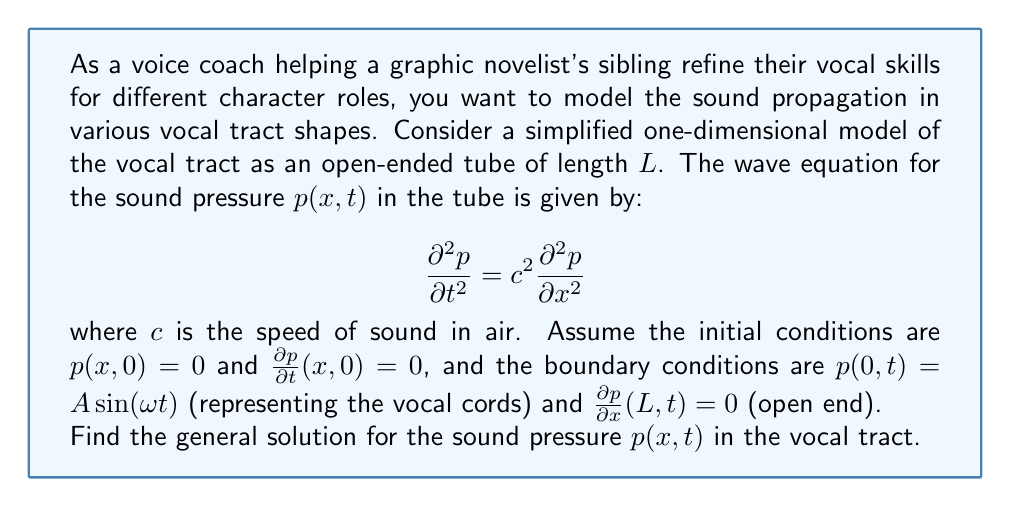Teach me how to tackle this problem. To solve this problem, we'll use the method of separation of variables and follow these steps:

1) Assume a solution of the form $p(x,t) = X(x)T(t)$.

2) Substitute this into the wave equation:
   $$X(x)T''(t) = c^2X''(x)T(t)$$

3) Separate variables:
   $$\frac{T''(t)}{c^2T(t)} = \frac{X''(x)}{X(x)} = -k^2$$

4) This gives us two ordinary differential equations:
   $$T''(t) + c^2k^2T(t) = 0$$
   $$X''(x) + k^2X(x) = 0$$

5) The general solutions are:
   $$T(t) = A\cos(ckt) + B\sin(ckt)$$
   $$X(x) = C\cos(kx) + D\sin(kx)$$

6) Apply the boundary condition at $x=L$:
   $$\frac{\partial p}{\partial x}(L,t) = 0 \implies X'(L) = 0$$
   $$-Ck\sin(kL) + Dk\cos(kL) = 0$$

7) This gives us the eigenvalue equation:
   $$\tan(kL) = \infty \implies kL = (2n-1)\frac{\pi}{2}, n = 1,2,3,...$$

8) The eigenvalues are:
   $$k_n = \frac{(2n-1)\pi}{2L}, n = 1,2,3,...$$

9) The corresponding eigenfunctions are:
   $$X_n(x) = \cos(k_nx)$$

10) The general solution is:
    $$p(x,t) = \sum_{n=1}^{\infty} [A_n\cos(ck_nt) + B_n\sin(ck_nt)]\cos(k_nx)$$

11) Apply the initial conditions:
    $$p(x,0) = 0 \implies A_n = 0 \text{ for all } n$$
    $$\frac{\partial p}{\partial t}(x,0) = 0 \implies B_n = 0 \text{ for all } n$$

12) Apply the boundary condition at $x=0$:
    $$p(0,t) = A\sin(\omega t) = \sum_{n=1}^{\infty} B_n\sin(ck_nt)$$

13) This implies that $\omega = ck_n$ for some $n$, and all other $B_n = 0$ except for this $n$.

14) The final solution is:
    $$p(x,t) = A\sin(\omega t)\cos(\frac{\omega x}{c})$$
Answer: $$p(x,t) = A\sin(\omega t)\cos(\frac{\omega x}{c})$$
where $\omega = \frac{(2n-1)\pi c}{2L}$ for some integer $n$. 